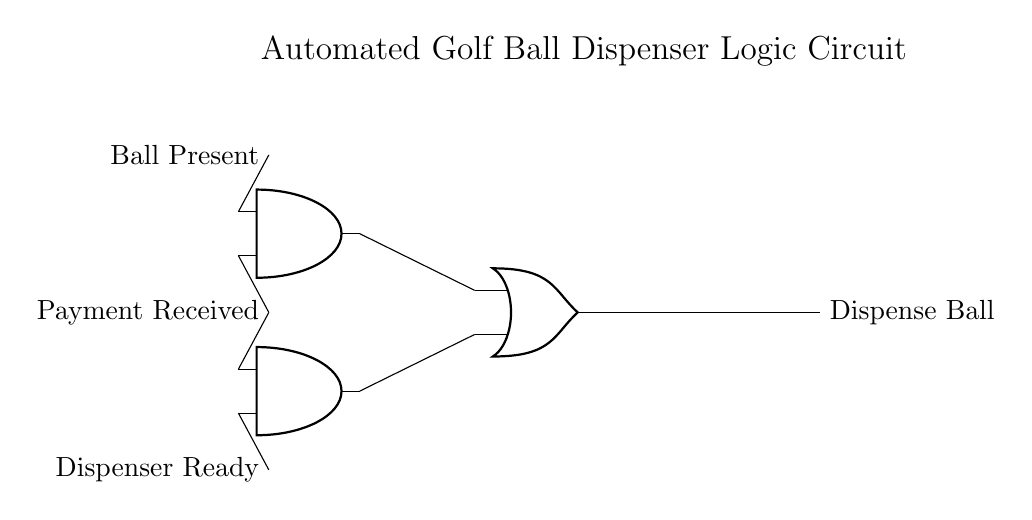What are the inputs to the AND gate? The inputs to the AND gate are "Ball Present" and "Payment Received," as shown by the connections from these two inputs directly to the AND gate.
Answer: Ball Present, Payment Received How many AND gates are in this circuit? There are two AND gates present in the circuit, which are indicated by the separate symbols within the diagram.
Answer: 2 What is the output of the OR gate? The output of the OR gate is "Dispense Ball," as indicated by the label connected to the output of the OR gate.
Answer: Dispense Ball What condition must be met for the AND gate to output a signal? For the AND gate to output a signal, both inputs ("Ball Present" and "Payment Received") must be true since an AND gate outputs high only when all its inputs are high.
Answer: Both inputs true Which component controls the final action of dispensing the ball? The final action of dispensing the ball is controlled by the output of the OR gate, which activates the dispensing mechanism when it receives a true signal.
Answer: OR gate output What happens if the "Dispenser Ready" input is false? If the "Dispenser Ready" input is false, the second AND gate will not output a true signal, thereby preventing the OR gate from activating the dispensing action, regardless of the other inputs.
Answer: No dispensing action 